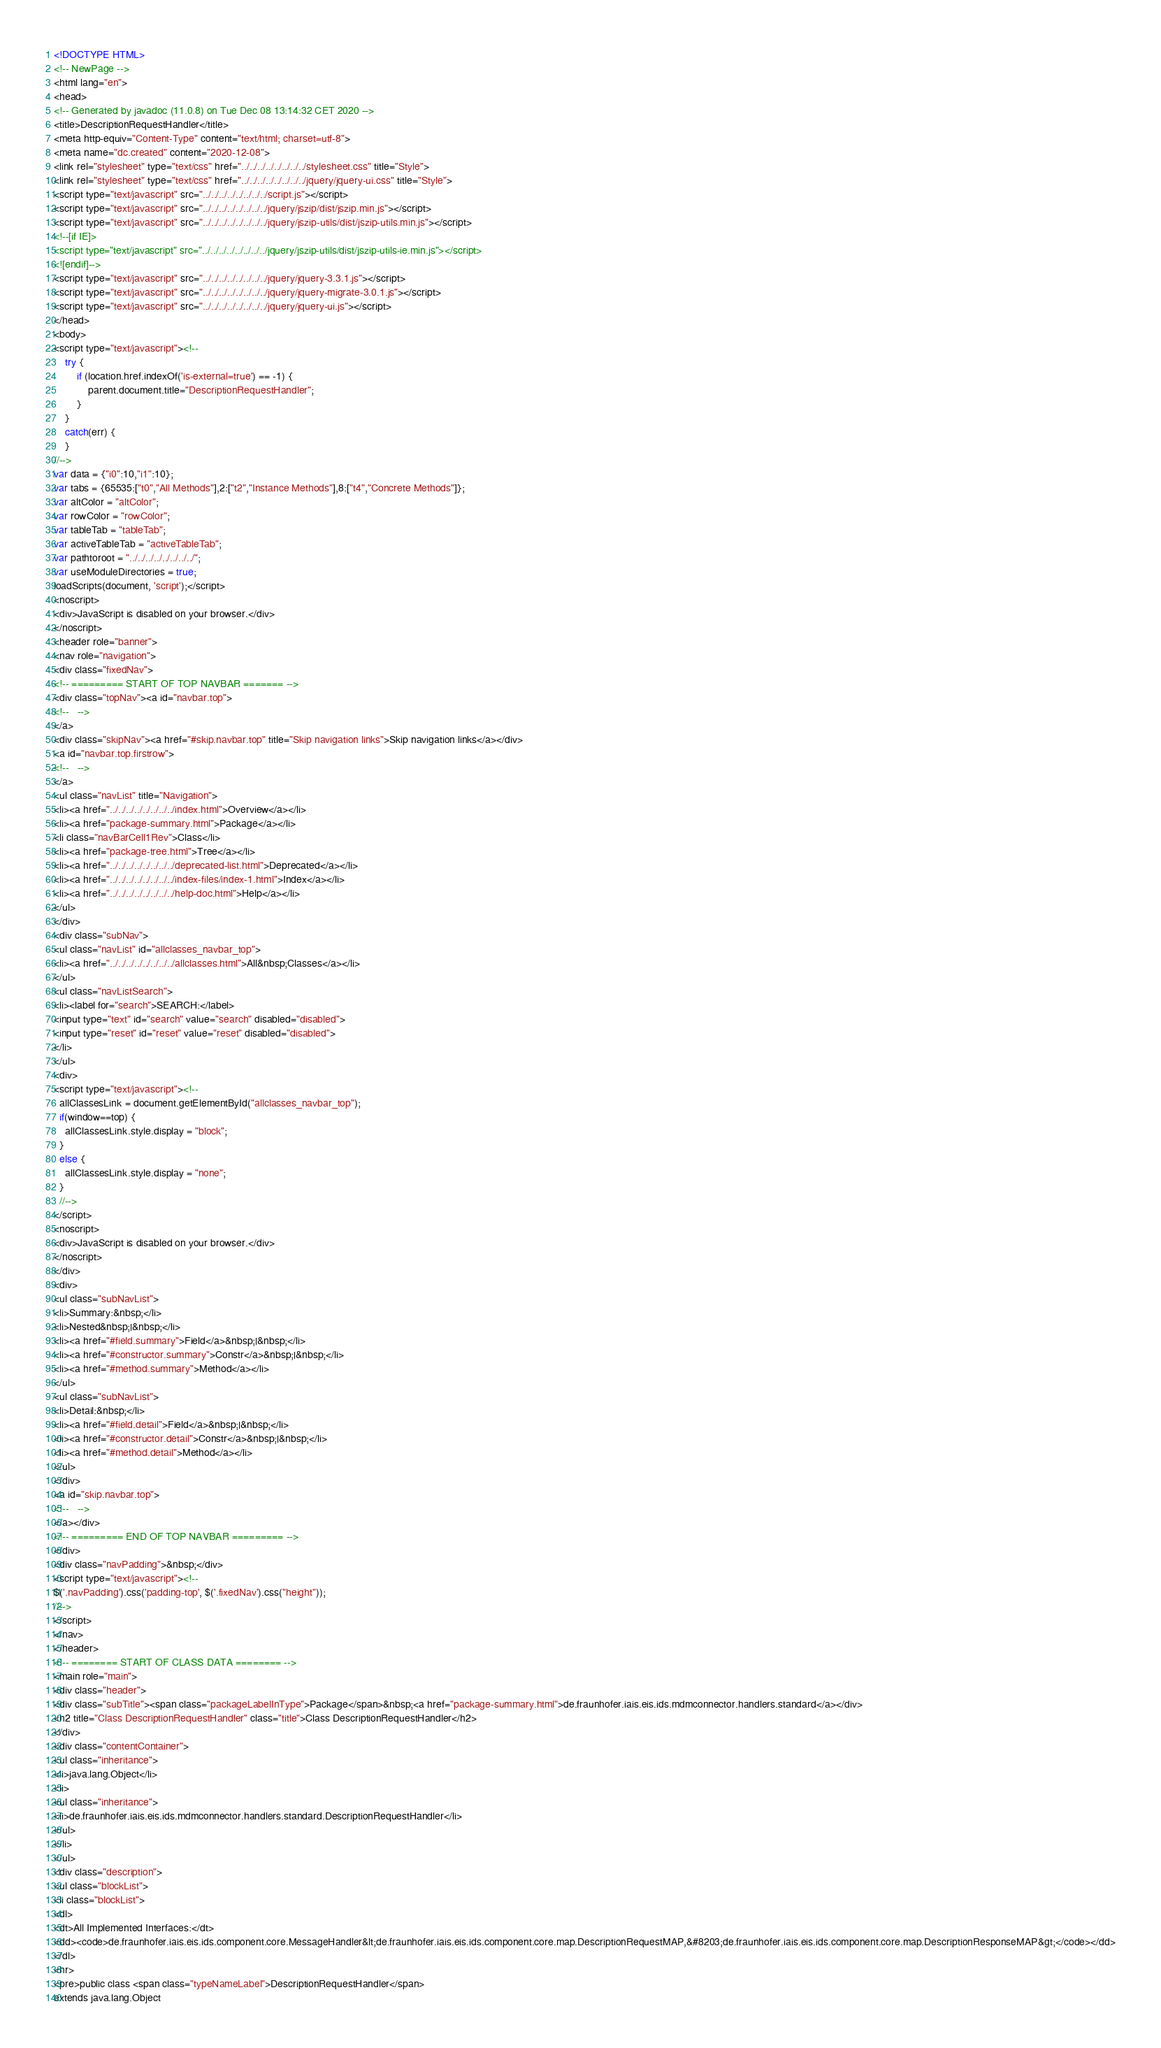<code> <loc_0><loc_0><loc_500><loc_500><_HTML_><!DOCTYPE HTML>
<!-- NewPage -->
<html lang="en">
<head>
<!-- Generated by javadoc (11.0.8) on Tue Dec 08 13:14:32 CET 2020 -->
<title>DescriptionRequestHandler</title>
<meta http-equiv="Content-Type" content="text/html; charset=utf-8">
<meta name="dc.created" content="2020-12-08">
<link rel="stylesheet" type="text/css" href="../../../../../../../../stylesheet.css" title="Style">
<link rel="stylesheet" type="text/css" href="../../../../../../../../jquery/jquery-ui.css" title="Style">
<script type="text/javascript" src="../../../../../../../../script.js"></script>
<script type="text/javascript" src="../../../../../../../../jquery/jszip/dist/jszip.min.js"></script>
<script type="text/javascript" src="../../../../../../../../jquery/jszip-utils/dist/jszip-utils.min.js"></script>
<!--[if IE]>
<script type="text/javascript" src="../../../../../../../../jquery/jszip-utils/dist/jszip-utils-ie.min.js"></script>
<![endif]-->
<script type="text/javascript" src="../../../../../../../../jquery/jquery-3.3.1.js"></script>
<script type="text/javascript" src="../../../../../../../../jquery/jquery-migrate-3.0.1.js"></script>
<script type="text/javascript" src="../../../../../../../../jquery/jquery-ui.js"></script>
</head>
<body>
<script type="text/javascript"><!--
    try {
        if (location.href.indexOf('is-external=true') == -1) {
            parent.document.title="DescriptionRequestHandler";
        }
    }
    catch(err) {
    }
//-->
var data = {"i0":10,"i1":10};
var tabs = {65535:["t0","All Methods"],2:["t2","Instance Methods"],8:["t4","Concrete Methods"]};
var altColor = "altColor";
var rowColor = "rowColor";
var tableTab = "tableTab";
var activeTableTab = "activeTableTab";
var pathtoroot = "../../../../../../../../";
var useModuleDirectories = true;
loadScripts(document, 'script');</script>
<noscript>
<div>JavaScript is disabled on your browser.</div>
</noscript>
<header role="banner">
<nav role="navigation">
<div class="fixedNav">
<!-- ========= START OF TOP NAVBAR ======= -->
<div class="topNav"><a id="navbar.top">
<!--   -->
</a>
<div class="skipNav"><a href="#skip.navbar.top" title="Skip navigation links">Skip navigation links</a></div>
<a id="navbar.top.firstrow">
<!--   -->
</a>
<ul class="navList" title="Navigation">
<li><a href="../../../../../../../../index.html">Overview</a></li>
<li><a href="package-summary.html">Package</a></li>
<li class="navBarCell1Rev">Class</li>
<li><a href="package-tree.html">Tree</a></li>
<li><a href="../../../../../../../../deprecated-list.html">Deprecated</a></li>
<li><a href="../../../../../../../../index-files/index-1.html">Index</a></li>
<li><a href="../../../../../../../../help-doc.html">Help</a></li>
</ul>
</div>
<div class="subNav">
<ul class="navList" id="allclasses_navbar_top">
<li><a href="../../../../../../../../allclasses.html">All&nbsp;Classes</a></li>
</ul>
<ul class="navListSearch">
<li><label for="search">SEARCH:</label>
<input type="text" id="search" value="search" disabled="disabled">
<input type="reset" id="reset" value="reset" disabled="disabled">
</li>
</ul>
<div>
<script type="text/javascript"><!--
  allClassesLink = document.getElementById("allclasses_navbar_top");
  if(window==top) {
    allClassesLink.style.display = "block";
  }
  else {
    allClassesLink.style.display = "none";
  }
  //-->
</script>
<noscript>
<div>JavaScript is disabled on your browser.</div>
</noscript>
</div>
<div>
<ul class="subNavList">
<li>Summary:&nbsp;</li>
<li>Nested&nbsp;|&nbsp;</li>
<li><a href="#field.summary">Field</a>&nbsp;|&nbsp;</li>
<li><a href="#constructor.summary">Constr</a>&nbsp;|&nbsp;</li>
<li><a href="#method.summary">Method</a></li>
</ul>
<ul class="subNavList">
<li>Detail:&nbsp;</li>
<li><a href="#field.detail">Field</a>&nbsp;|&nbsp;</li>
<li><a href="#constructor.detail">Constr</a>&nbsp;|&nbsp;</li>
<li><a href="#method.detail">Method</a></li>
</ul>
</div>
<a id="skip.navbar.top">
<!--   -->
</a></div>
<!-- ========= END OF TOP NAVBAR ========= -->
</div>
<div class="navPadding">&nbsp;</div>
<script type="text/javascript"><!--
$('.navPadding').css('padding-top', $('.fixedNav').css("height"));
//-->
</script>
</nav>
</header>
<!-- ======== START OF CLASS DATA ======== -->
<main role="main">
<div class="header">
<div class="subTitle"><span class="packageLabelInType">Package</span>&nbsp;<a href="package-summary.html">de.fraunhofer.iais.eis.ids.mdmconnector.handlers.standard</a></div>
<h2 title="Class DescriptionRequestHandler" class="title">Class DescriptionRequestHandler</h2>
</div>
<div class="contentContainer">
<ul class="inheritance">
<li>java.lang.Object</li>
<li>
<ul class="inheritance">
<li>de.fraunhofer.iais.eis.ids.mdmconnector.handlers.standard.DescriptionRequestHandler</li>
</ul>
</li>
</ul>
<div class="description">
<ul class="blockList">
<li class="blockList">
<dl>
<dt>All Implemented Interfaces:</dt>
<dd><code>de.fraunhofer.iais.eis.ids.component.core.MessageHandler&lt;de.fraunhofer.iais.eis.ids.component.core.map.DescriptionRequestMAP,&#8203;de.fraunhofer.iais.eis.ids.component.core.map.DescriptionResponseMAP&gt;</code></dd>
</dl>
<hr>
<pre>public class <span class="typeNameLabel">DescriptionRequestHandler</span>
extends java.lang.Object</code> 